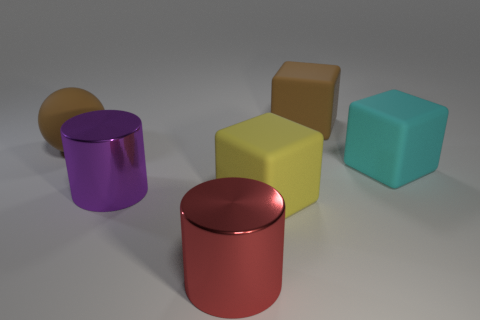Add 1 rubber things. How many objects exist? 7 Subtract all balls. How many objects are left? 5 Add 1 matte blocks. How many matte blocks are left? 4 Add 1 big blue rubber blocks. How many big blue rubber blocks exist? 1 Subtract 0 blue balls. How many objects are left? 6 Subtract all large metallic cylinders. Subtract all big metallic things. How many objects are left? 2 